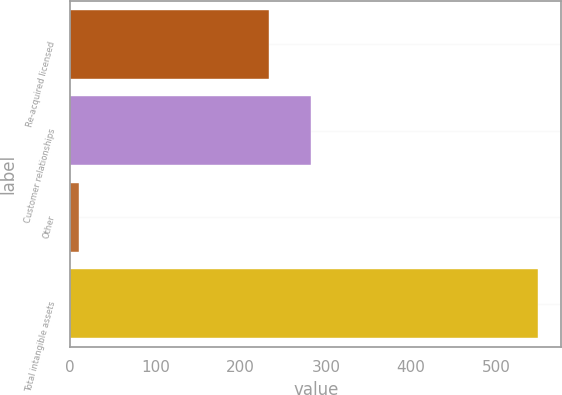Convert chart. <chart><loc_0><loc_0><loc_500><loc_500><bar_chart><fcel>Re-acquired licensed<fcel>Customer relationships<fcel>Other<fcel>Total intangible assets<nl><fcel>232.7<fcel>282.35<fcel>10.1<fcel>548.95<nl></chart> 